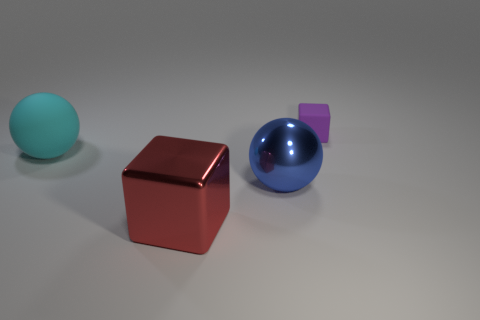Are the objects arranged in any particular pattern? The objects appear to be placed in an informal staggered arrangement, creating an aesthetically pleasing composition that guides the viewer's eye across the image. Do the colors of the objects carry any specific significance or are they randomly chosen? While the colors could be randomly selected, they might also have been chosen for their contrasting properties. The cyan, purple, and reddish-brown hues provide a visually engaging palette that demonstrates how diverse colors can come together harmoniously. 